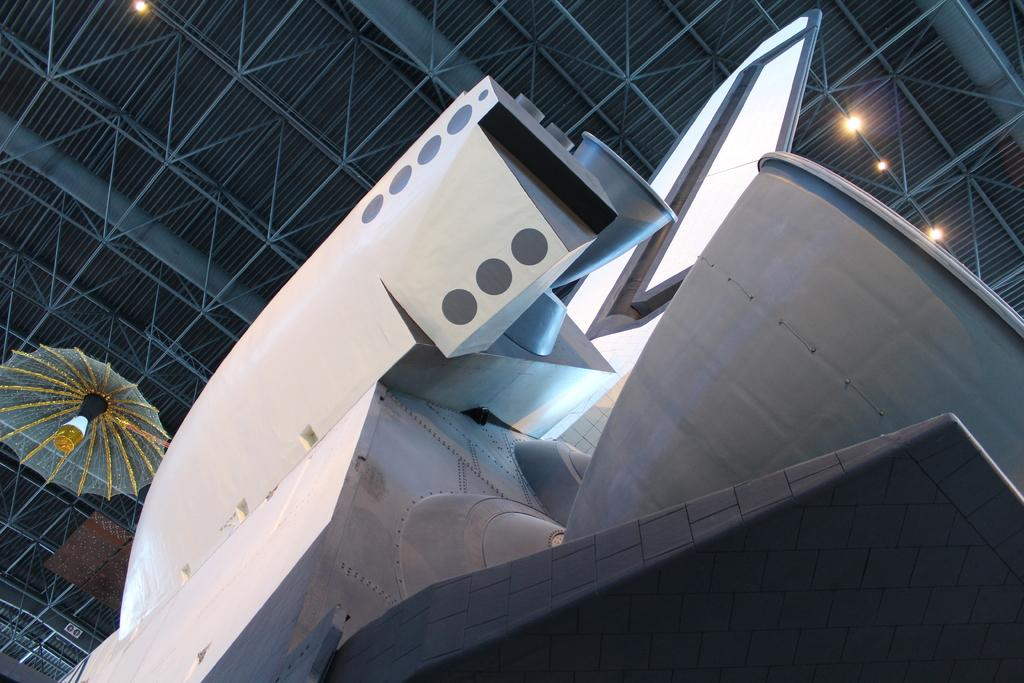What is the main subject of the image? The main subject of the image is a rocket. Can you describe the color of the rocket? The rocket is white and grey in color. What can be seen in the background of the image? There is a ceiling visible in the background of the image. What features are present on the ceiling? There are lights attached to the ceiling, and there is an object attached to the ceiling. Who is the owner of the coast visible in the image? There is no coast visible in the image; it features a rocket and a ceiling with lights and an object attached. 